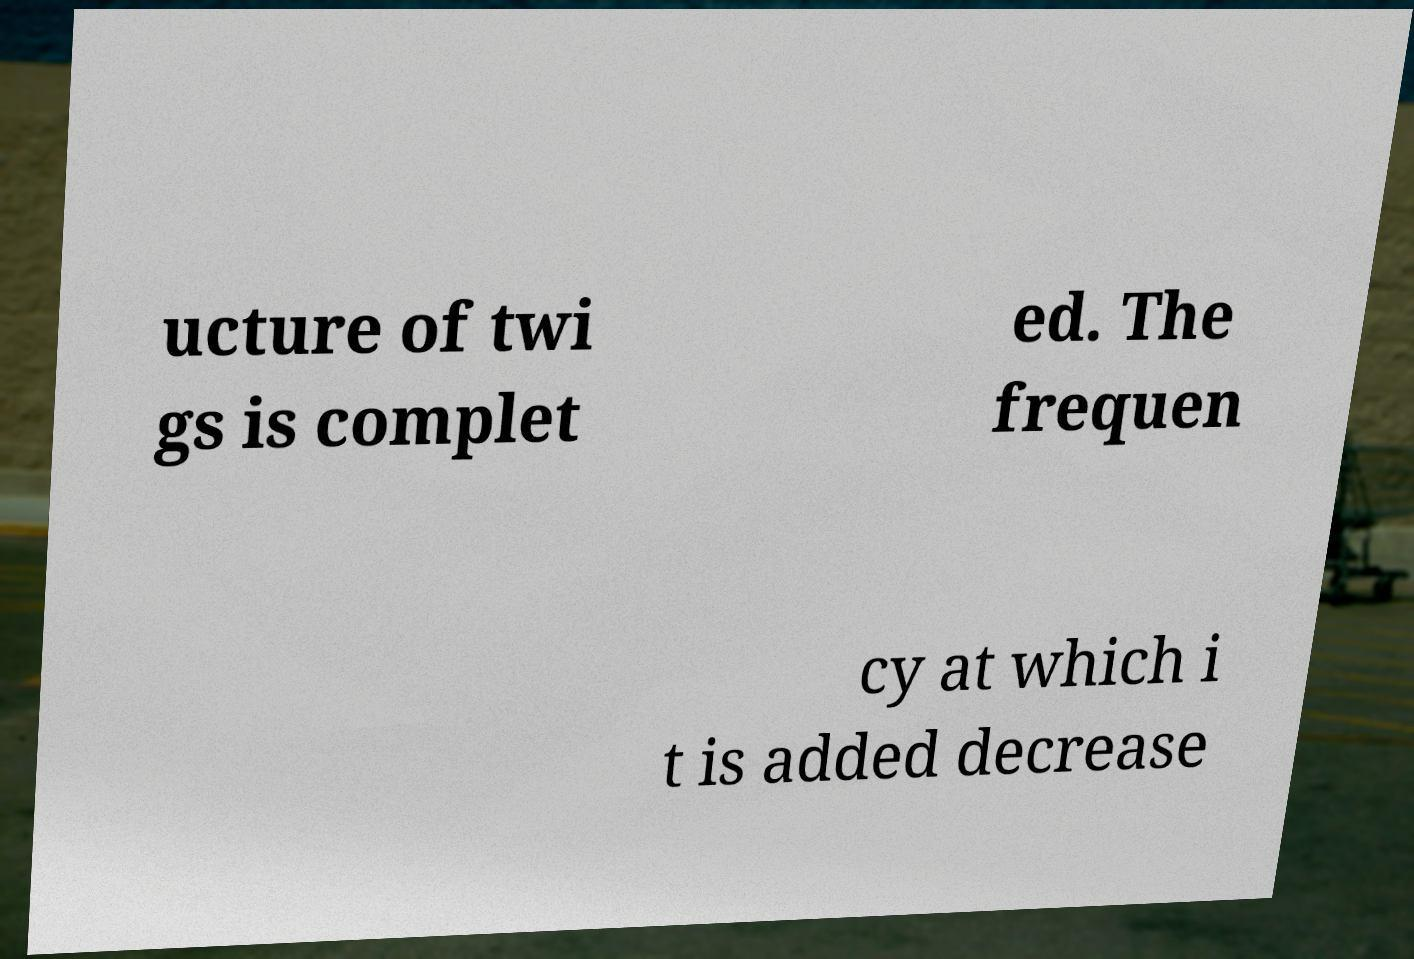For documentation purposes, I need the text within this image transcribed. Could you provide that? ucture of twi gs is complet ed. The frequen cy at which i t is added decrease 